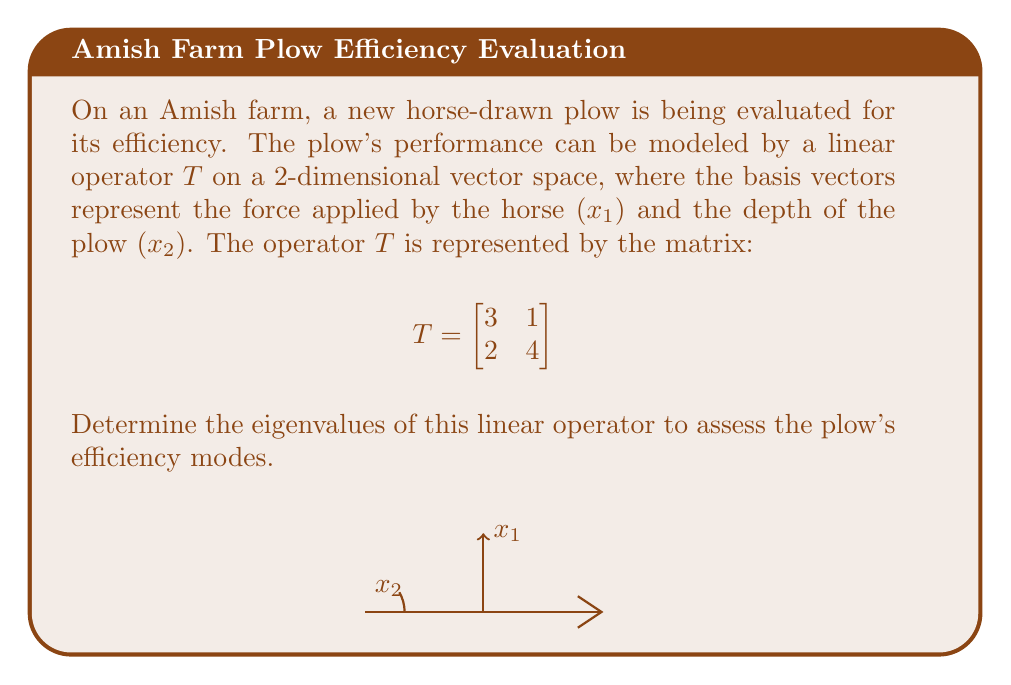Show me your answer to this math problem. To find the eigenvalues of the linear operator $T$, we follow these steps:

1) The eigenvalues $\lambda$ satisfy the characteristic equation:
   $\det(T - \lambda I) = 0$, where $I$ is the 2x2 identity matrix.

2) Expand the determinant:
   $$\det\begin{bmatrix}
   3-\lambda & 1 \\
   2 & 4-\lambda
   \end{bmatrix} = 0$$

3) Calculate the determinant:
   $(3-\lambda)(4-\lambda) - 2 = 0$

4) Expand the equation:
   $\lambda^2 - 7\lambda + 10 = 0$

5) Solve this quadratic equation using the quadratic formula:
   $\lambda = \frac{-b \pm \sqrt{b^2 - 4ac}}{2a}$

   Where $a=1$, $b=-7$, and $c=10$

6) Substitute these values:
   $\lambda = \frac{7 \pm \sqrt{49 - 40}}{2} = \frac{7 \pm \sqrt{9}}{2} = \frac{7 \pm 3}{2}$

7) Therefore, the eigenvalues are:
   $\lambda_1 = \frac{7 + 3}{2} = 5$ and $\lambda_2 = \frac{7 - 3}{2} = 2$
Answer: $\lambda_1 = 5$, $\lambda_2 = 2$ 